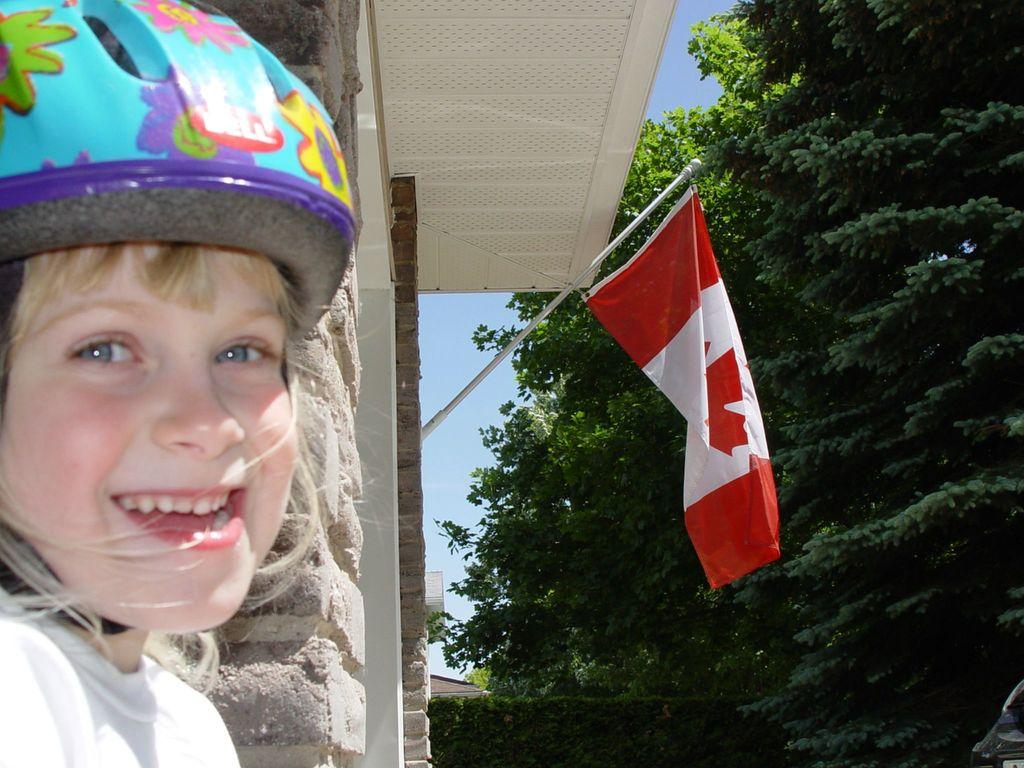What is the main subject of the image? There is a child in the image. What is the child wearing in the image? The child is wearing a helmet. What can be seen attached to a building in the image? There is a flag attached to a building in the image. What type of natural environment is visible in the image? Trees are visible in the image. What is visible in the background of the image? The sky is visible in the image. How does the cork expand when it comes into contact with the liquid in the image? There is no cork present in the image, so it is not possible to observe its expansion when it comes into contact with a liquid. 